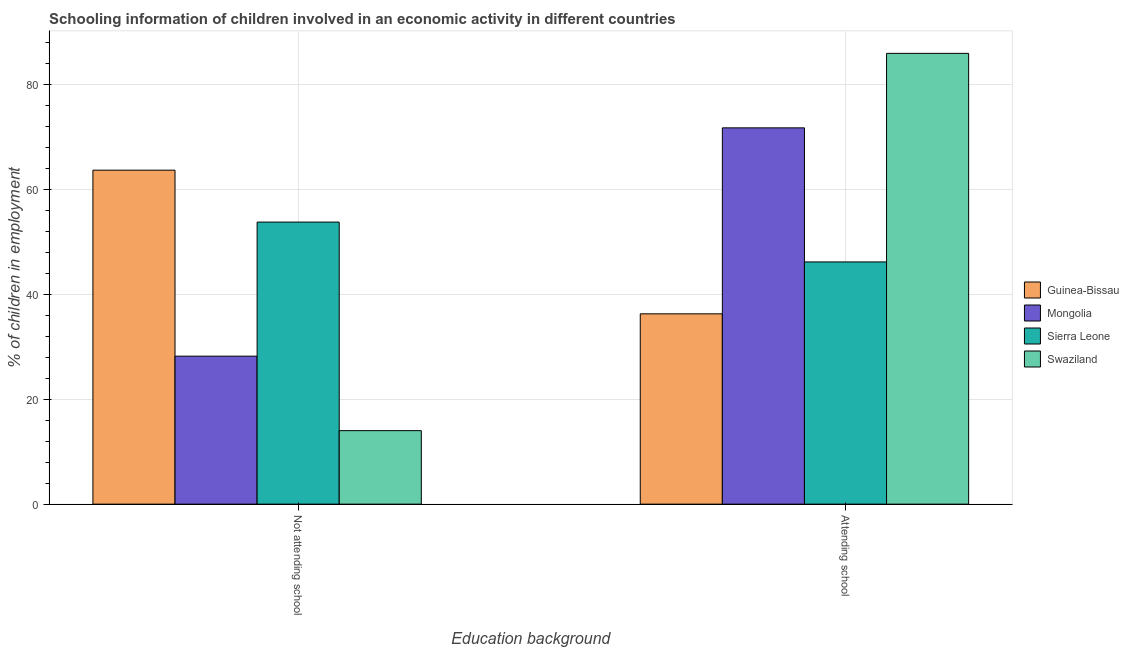Are the number of bars per tick equal to the number of legend labels?
Provide a succinct answer. Yes. Are the number of bars on each tick of the X-axis equal?
Keep it short and to the point. Yes. How many bars are there on the 1st tick from the left?
Make the answer very short. 4. What is the label of the 2nd group of bars from the left?
Make the answer very short. Attending school. What is the percentage of employed children who are not attending school in Mongolia?
Make the answer very short. 28.23. Across all countries, what is the maximum percentage of employed children who are attending school?
Keep it short and to the point. 85.98. Across all countries, what is the minimum percentage of employed children who are not attending school?
Your answer should be compact. 14.02. In which country was the percentage of employed children who are attending school maximum?
Your answer should be compact. Swaziland. In which country was the percentage of employed children who are not attending school minimum?
Make the answer very short. Swaziland. What is the total percentage of employed children who are not attending school in the graph?
Give a very brief answer. 159.75. What is the difference between the percentage of employed children who are not attending school in Mongolia and that in Guinea-Bissau?
Your answer should be very brief. -35.47. What is the difference between the percentage of employed children who are attending school in Swaziland and the percentage of employed children who are not attending school in Sierra Leone?
Provide a short and direct response. 32.18. What is the average percentage of employed children who are attending school per country?
Provide a succinct answer. 60.06. What is the difference between the percentage of employed children who are not attending school and percentage of employed children who are attending school in Sierra Leone?
Your answer should be compact. 7.6. What is the ratio of the percentage of employed children who are not attending school in Guinea-Bissau to that in Sierra Leone?
Keep it short and to the point. 1.18. Is the percentage of employed children who are not attending school in Mongolia less than that in Sierra Leone?
Your response must be concise. Yes. In how many countries, is the percentage of employed children who are attending school greater than the average percentage of employed children who are attending school taken over all countries?
Offer a very short reply. 2. What does the 1st bar from the left in Attending school represents?
Provide a short and direct response. Guinea-Bissau. What does the 2nd bar from the right in Not attending school represents?
Provide a short and direct response. Sierra Leone. Are the values on the major ticks of Y-axis written in scientific E-notation?
Your answer should be very brief. No. How many legend labels are there?
Provide a succinct answer. 4. How are the legend labels stacked?
Give a very brief answer. Vertical. What is the title of the graph?
Offer a very short reply. Schooling information of children involved in an economic activity in different countries. Does "Germany" appear as one of the legend labels in the graph?
Make the answer very short. No. What is the label or title of the X-axis?
Make the answer very short. Education background. What is the label or title of the Y-axis?
Your response must be concise. % of children in employment. What is the % of children in employment in Guinea-Bissau in Not attending school?
Provide a short and direct response. 63.7. What is the % of children in employment of Mongolia in Not attending school?
Offer a very short reply. 28.23. What is the % of children in employment in Sierra Leone in Not attending school?
Give a very brief answer. 53.8. What is the % of children in employment in Swaziland in Not attending school?
Ensure brevity in your answer.  14.02. What is the % of children in employment in Guinea-Bissau in Attending school?
Your answer should be very brief. 36.3. What is the % of children in employment of Mongolia in Attending school?
Make the answer very short. 71.77. What is the % of children in employment of Sierra Leone in Attending school?
Your response must be concise. 46.2. What is the % of children in employment of Swaziland in Attending school?
Give a very brief answer. 85.98. Across all Education background, what is the maximum % of children in employment in Guinea-Bissau?
Make the answer very short. 63.7. Across all Education background, what is the maximum % of children in employment of Mongolia?
Make the answer very short. 71.77. Across all Education background, what is the maximum % of children in employment in Sierra Leone?
Offer a very short reply. 53.8. Across all Education background, what is the maximum % of children in employment of Swaziland?
Your answer should be very brief. 85.98. Across all Education background, what is the minimum % of children in employment of Guinea-Bissau?
Keep it short and to the point. 36.3. Across all Education background, what is the minimum % of children in employment in Mongolia?
Provide a succinct answer. 28.23. Across all Education background, what is the minimum % of children in employment of Sierra Leone?
Make the answer very short. 46.2. Across all Education background, what is the minimum % of children in employment in Swaziland?
Your answer should be compact. 14.02. What is the total % of children in employment in Guinea-Bissau in the graph?
Your answer should be very brief. 100. What is the total % of children in employment in Sierra Leone in the graph?
Ensure brevity in your answer.  100. What is the difference between the % of children in employment of Guinea-Bissau in Not attending school and that in Attending school?
Give a very brief answer. 27.4. What is the difference between the % of children in employment of Mongolia in Not attending school and that in Attending school?
Provide a succinct answer. -43.55. What is the difference between the % of children in employment of Swaziland in Not attending school and that in Attending school?
Give a very brief answer. -71.96. What is the difference between the % of children in employment in Guinea-Bissau in Not attending school and the % of children in employment in Mongolia in Attending school?
Offer a very short reply. -8.07. What is the difference between the % of children in employment in Guinea-Bissau in Not attending school and the % of children in employment in Swaziland in Attending school?
Offer a terse response. -22.28. What is the difference between the % of children in employment in Mongolia in Not attending school and the % of children in employment in Sierra Leone in Attending school?
Your answer should be compact. -17.97. What is the difference between the % of children in employment in Mongolia in Not attending school and the % of children in employment in Swaziland in Attending school?
Make the answer very short. -57.75. What is the difference between the % of children in employment in Sierra Leone in Not attending school and the % of children in employment in Swaziland in Attending school?
Make the answer very short. -32.18. What is the average % of children in employment of Guinea-Bissau per Education background?
Ensure brevity in your answer.  50. What is the average % of children in employment of Sierra Leone per Education background?
Ensure brevity in your answer.  50. What is the average % of children in employment of Swaziland per Education background?
Your response must be concise. 50. What is the difference between the % of children in employment in Guinea-Bissau and % of children in employment in Mongolia in Not attending school?
Keep it short and to the point. 35.47. What is the difference between the % of children in employment in Guinea-Bissau and % of children in employment in Sierra Leone in Not attending school?
Your answer should be compact. 9.9. What is the difference between the % of children in employment in Guinea-Bissau and % of children in employment in Swaziland in Not attending school?
Your answer should be compact. 49.68. What is the difference between the % of children in employment in Mongolia and % of children in employment in Sierra Leone in Not attending school?
Your answer should be very brief. -25.57. What is the difference between the % of children in employment of Mongolia and % of children in employment of Swaziland in Not attending school?
Offer a very short reply. 14.21. What is the difference between the % of children in employment in Sierra Leone and % of children in employment in Swaziland in Not attending school?
Provide a short and direct response. 39.78. What is the difference between the % of children in employment in Guinea-Bissau and % of children in employment in Mongolia in Attending school?
Your response must be concise. -35.47. What is the difference between the % of children in employment of Guinea-Bissau and % of children in employment of Sierra Leone in Attending school?
Ensure brevity in your answer.  -9.9. What is the difference between the % of children in employment in Guinea-Bissau and % of children in employment in Swaziland in Attending school?
Your response must be concise. -49.68. What is the difference between the % of children in employment of Mongolia and % of children in employment of Sierra Leone in Attending school?
Offer a very short reply. 25.57. What is the difference between the % of children in employment of Mongolia and % of children in employment of Swaziland in Attending school?
Ensure brevity in your answer.  -14.21. What is the difference between the % of children in employment of Sierra Leone and % of children in employment of Swaziland in Attending school?
Your response must be concise. -39.78. What is the ratio of the % of children in employment in Guinea-Bissau in Not attending school to that in Attending school?
Offer a very short reply. 1.75. What is the ratio of the % of children in employment of Mongolia in Not attending school to that in Attending school?
Your answer should be very brief. 0.39. What is the ratio of the % of children in employment of Sierra Leone in Not attending school to that in Attending school?
Offer a terse response. 1.16. What is the ratio of the % of children in employment in Swaziland in Not attending school to that in Attending school?
Give a very brief answer. 0.16. What is the difference between the highest and the second highest % of children in employment in Guinea-Bissau?
Your response must be concise. 27.4. What is the difference between the highest and the second highest % of children in employment in Mongolia?
Provide a succinct answer. 43.55. What is the difference between the highest and the second highest % of children in employment in Swaziland?
Keep it short and to the point. 71.96. What is the difference between the highest and the lowest % of children in employment in Guinea-Bissau?
Provide a short and direct response. 27.4. What is the difference between the highest and the lowest % of children in employment in Mongolia?
Provide a short and direct response. 43.55. What is the difference between the highest and the lowest % of children in employment of Sierra Leone?
Make the answer very short. 7.6. What is the difference between the highest and the lowest % of children in employment in Swaziland?
Make the answer very short. 71.96. 